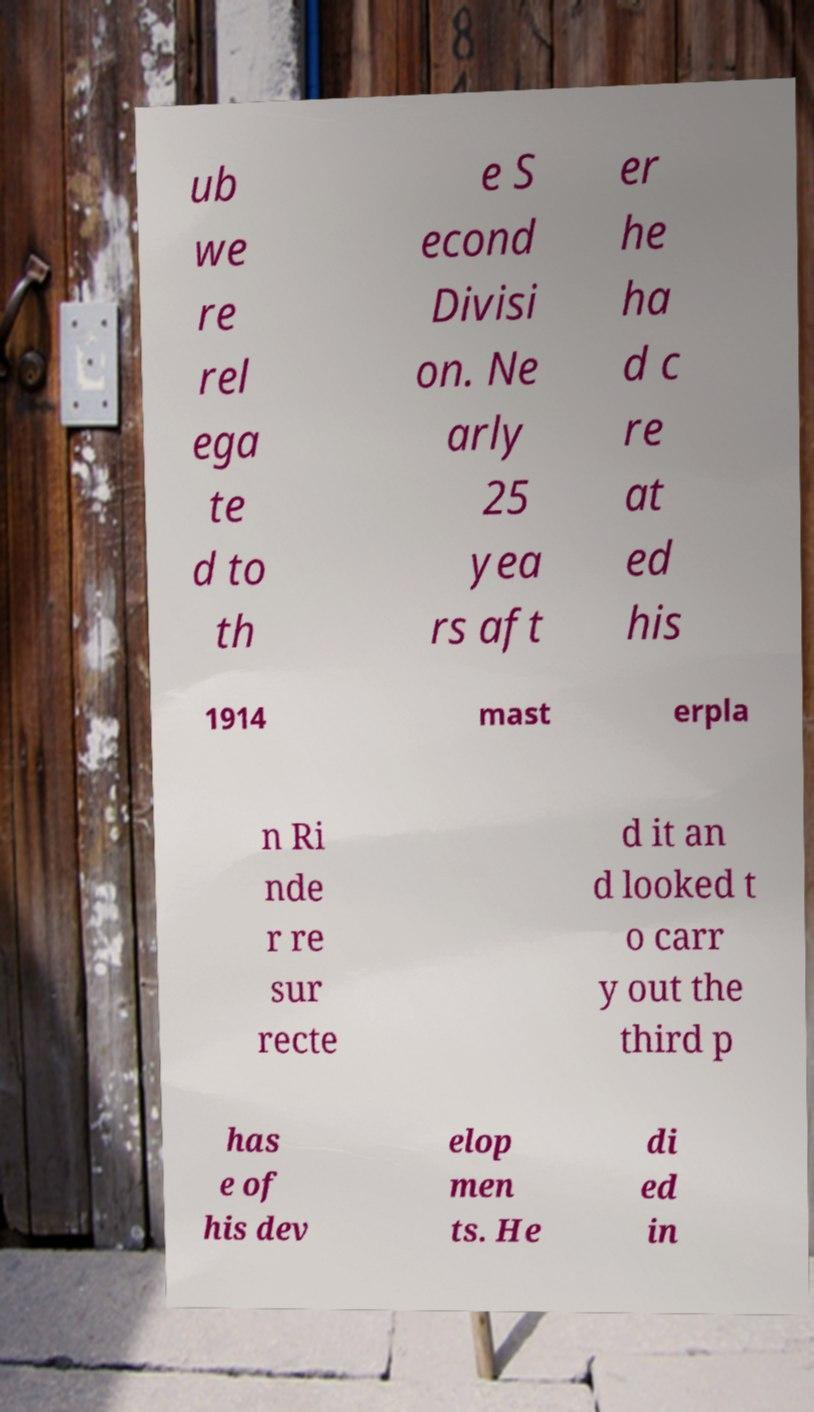Please read and relay the text visible in this image. What does it say? ub we re rel ega te d to th e S econd Divisi on. Ne arly 25 yea rs aft er he ha d c re at ed his 1914 mast erpla n Ri nde r re sur recte d it an d looked t o carr y out the third p has e of his dev elop men ts. He di ed in 